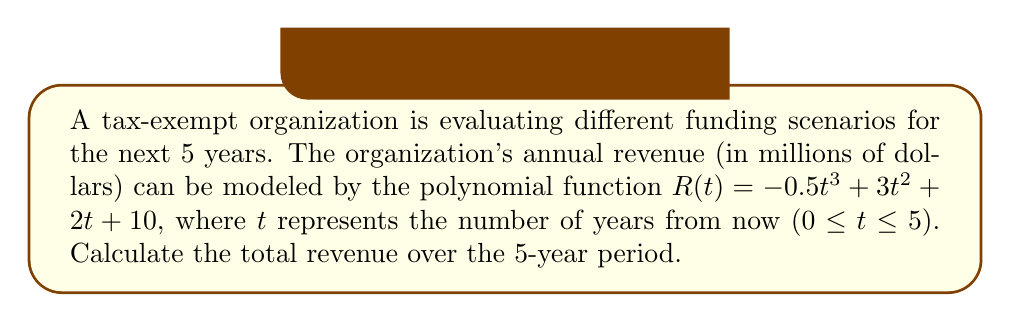Solve this math problem. To calculate the total revenue over the 5-year period, we need to find the definite integral of the revenue function from t = 0 to t = 5.

1) The revenue function is $R(t) = -0.5t^3 + 3t^2 + 2t + 10$

2) We need to integrate this function from 0 to 5:

   $$\int_0^5 (-0.5t^3 + 3t^2 + 2t + 10) dt$$

3) Integrate each term:
   $$\left[-\frac{1}{8}t^4 + t^3 + t^2 + 10t\right]_0^5$$

4) Evaluate the integral at t = 5 and t = 0:

   At t = 5: $-\frac{1}{8}(5^4) + (5^3) + (5^2) + 10(5) = -78.125 + 125 + 25 + 50 = 121.875$
   
   At t = 0: $-\frac{1}{8}(0^4) + (0^3) + (0^2) + 10(0) = 0$

5) Subtract the lower bound from the upper bound:

   $121.875 - 0 = 121.875$

Therefore, the total revenue over the 5-year period is $121.875 million.
Answer: $121.875 million 